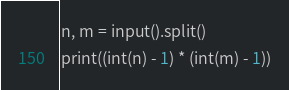Convert code to text. <code><loc_0><loc_0><loc_500><loc_500><_Python_>n, m = input().split()
print((int(n) - 1) * (int(m) - 1))</code> 